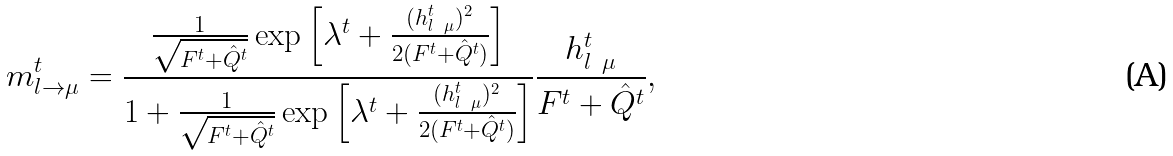<formula> <loc_0><loc_0><loc_500><loc_500>m _ { l \to \mu } ^ { t } = \frac { \frac { 1 } { \sqrt { F ^ { t } + \hat { Q } ^ { t } } } \exp \left [ \lambda ^ { t } + \frac { ( h _ { l \ \mu } ^ { t } ) ^ { 2 } } { 2 ( F ^ { t } + \hat { Q } ^ { t } ) } \right ] } { 1 + \frac { 1 } { \sqrt { F ^ { t } + \hat { Q } ^ { t } } } \exp \left [ \lambda ^ { t } + \frac { ( h _ { l \ \mu } ^ { t } ) ^ { 2 } } { 2 ( F ^ { t } + \hat { Q } ^ { t } ) } \right ] } \frac { h _ { l \ \mu } ^ { t } } { F ^ { t } + \hat { Q } ^ { t } } ,</formula> 